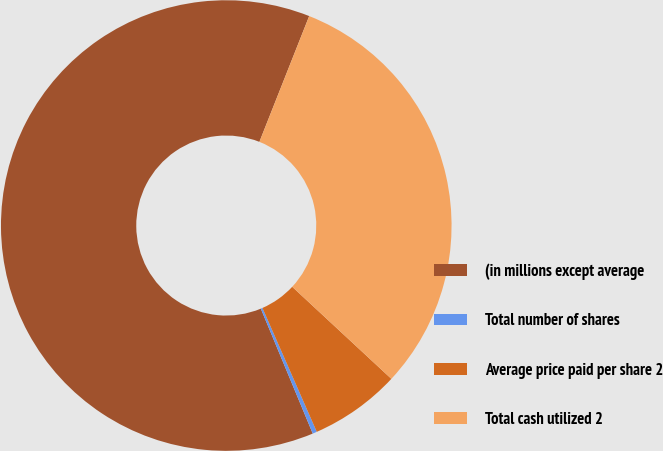Convert chart to OTSL. <chart><loc_0><loc_0><loc_500><loc_500><pie_chart><fcel>(in millions except average<fcel>Total number of shares<fcel>Average price paid per share 2<fcel>Total cash utilized 2<nl><fcel>62.27%<fcel>0.31%<fcel>6.51%<fcel>30.91%<nl></chart> 